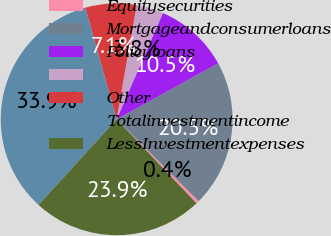<chart> <loc_0><loc_0><loc_500><loc_500><pie_chart><fcel>Equitysecurities<fcel>Mortgageandconsumerloans<fcel>Policyloans<fcel>Unnamed: 3<fcel>Other<fcel>Totalinvestmentincome<fcel>LessInvestmentexpenses<nl><fcel>0.42%<fcel>20.5%<fcel>10.46%<fcel>3.77%<fcel>7.12%<fcel>33.88%<fcel>23.85%<nl></chart> 